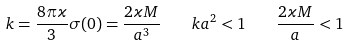<formula> <loc_0><loc_0><loc_500><loc_500>k = \frac { 8 \pi \varkappa } { 3 } \sigma ( 0 ) = \frac { 2 \varkappa M } { a ^ { 3 } } \quad k a ^ { 2 } < 1 \quad \frac { 2 \varkappa M } { a } < 1</formula> 